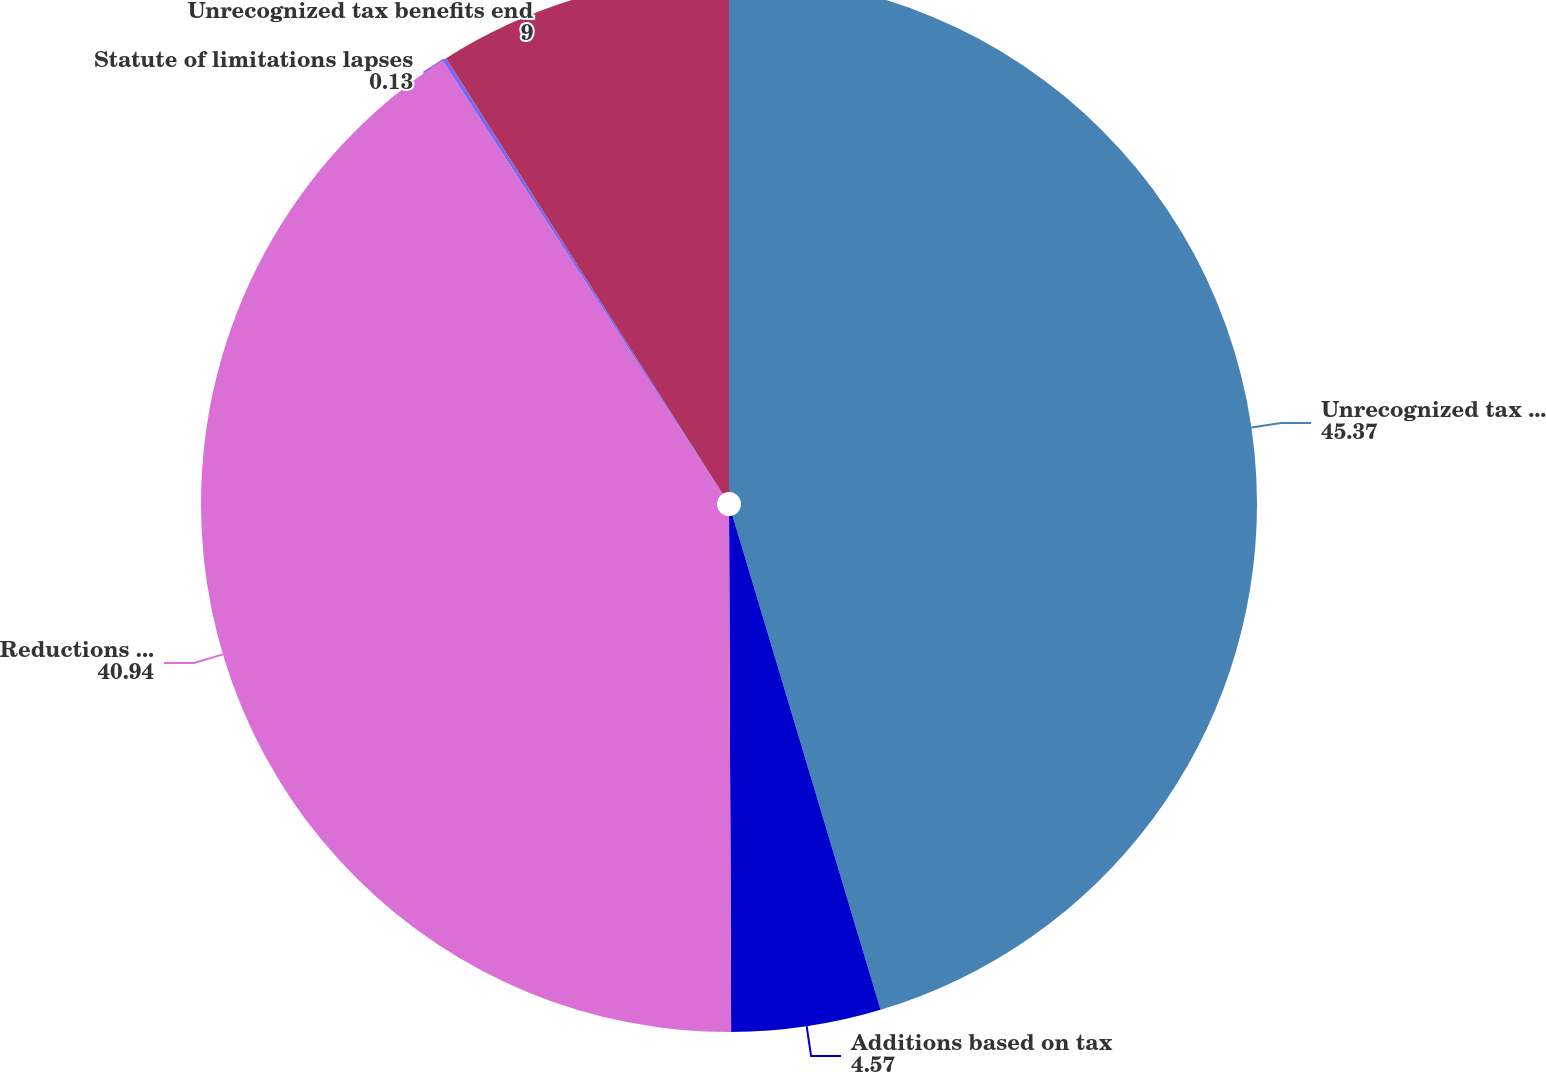Convert chart. <chart><loc_0><loc_0><loc_500><loc_500><pie_chart><fcel>Unrecognized tax benefits<fcel>Additions based on tax<fcel>Reductions based on tax<fcel>Statute of limitations lapses<fcel>Unrecognized tax benefits end<nl><fcel>45.37%<fcel>4.57%<fcel>40.94%<fcel>0.13%<fcel>9.0%<nl></chart> 